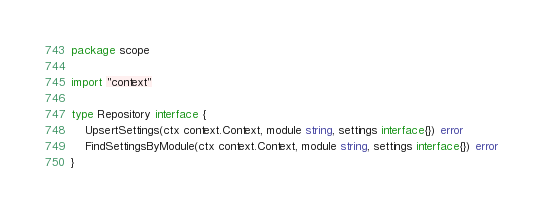<code> <loc_0><loc_0><loc_500><loc_500><_Go_>package scope

import "context"

type Repository interface {
	UpsertSettings(ctx context.Context, module string, settings interface{}) error
	FindSettingsByModule(ctx context.Context, module string, settings interface{}) error
}
</code> 